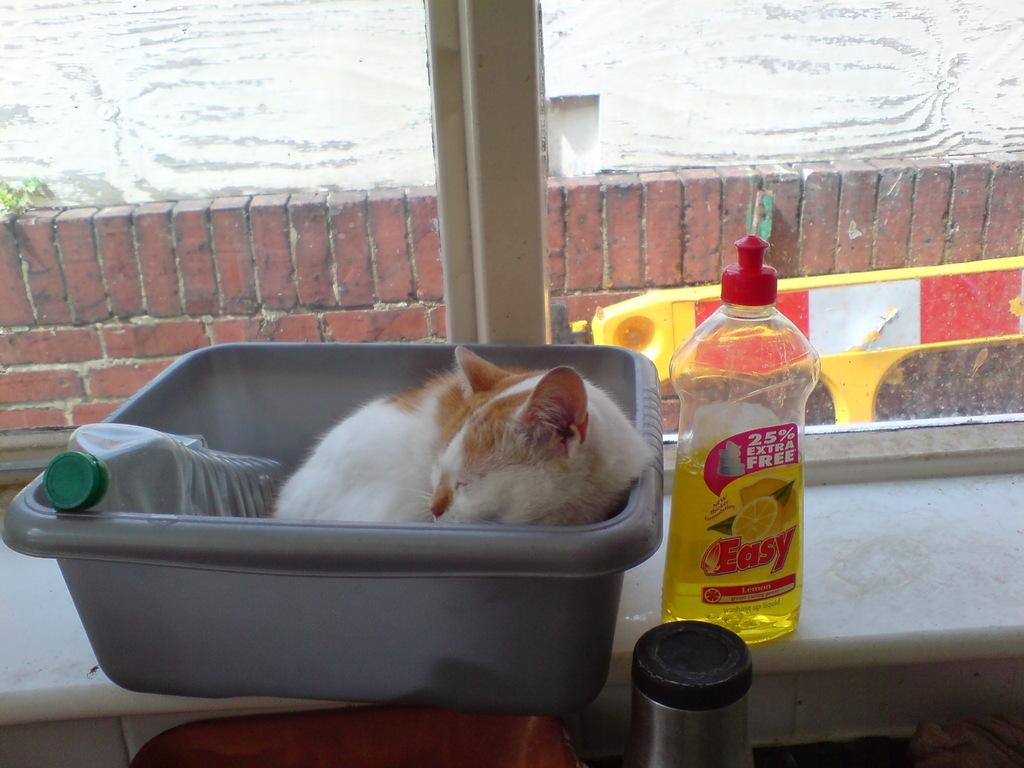What type of animal is in the container in the image? There is a cat in the container. What other objects are in the container? There is a bottle and another bottle in the container. What type of material is in the container? There are bricks in the container. What type of produce can be seen growing in the container? There is no produce growing in the container; it contains a cat, bottles, and bricks. What type of furniture is present in the container? There is no furniture present in the container. 